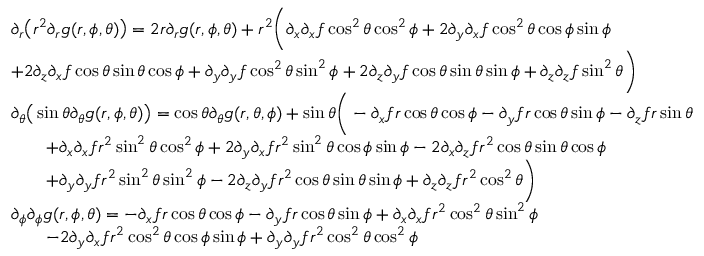<formula> <loc_0><loc_0><loc_500><loc_500>\begin{array} { r l } & { \partial _ { r } \left ( r ^ { 2 } \partial _ { r } g ( r , \phi , \theta ) \right ) = 2 r \partial _ { r } g ( r , \phi , \theta ) + r ^ { 2 } \left ( \partial _ { x } \partial _ { x } f \cos ^ { 2 } \theta \cos ^ { 2 } \phi + 2 \partial _ { y } \partial _ { x } f \cos ^ { 2 } \theta \cos \phi \sin \phi } \\ & { + 2 \partial _ { z } \partial _ { x } f \cos \theta \sin \theta \cos \phi + \partial _ { y } \partial _ { y } f \cos ^ { 2 } \theta \sin ^ { 2 } \phi + 2 \partial _ { z } \partial _ { y } f \cos \theta \sin \theta \sin \phi + \partial _ { z } \partial _ { z } f \sin ^ { 2 } \theta \right ) } \\ & { \partial _ { \theta } \left ( \sin \theta \partial _ { \theta } g ( r , \phi , \theta ) \right ) = \cos \theta \partial _ { \theta } g ( r , \theta , \phi ) + \sin \theta \left ( - \partial _ { x } f r \cos \theta \cos \phi - \partial _ { y } f r \cos \theta \sin \phi - \partial _ { z } f r \sin \theta } \\ & { \quad + \partial _ { x } \partial _ { x } f r ^ { 2 } \sin ^ { 2 } \theta \cos ^ { 2 } \phi + 2 \partial _ { y } \partial _ { x } f r ^ { 2 } \sin ^ { 2 } \theta \cos \phi \sin \phi - 2 \partial _ { x } \partial _ { z } f r ^ { 2 } \cos \theta \sin \theta \cos \phi } \\ & { \quad + \partial _ { y } \partial _ { y } f r ^ { 2 } \sin ^ { 2 } \theta \sin ^ { 2 } \phi - 2 \partial _ { z } \partial _ { y } f r ^ { 2 } \cos \theta \sin \theta \sin \phi + \partial _ { z } \partial _ { z } f r ^ { 2 } \cos ^ { 2 } \theta \right ) } \\ & { \partial _ { \phi } \partial _ { \phi } g ( r , \phi , \theta ) = - \partial _ { x } f r \cos \theta \cos \phi - \partial _ { y } f r \cos \theta \sin \phi + \partial _ { x } \partial _ { x } f r ^ { 2 } \cos ^ { 2 } \theta \sin ^ { 2 } \phi } \\ & { \quad - 2 \partial _ { y } \partial _ { x } f r ^ { 2 } \cos ^ { 2 } \theta \cos \phi \sin \phi + \partial _ { y } \partial _ { y } f r ^ { 2 } \cos ^ { 2 } \theta \cos ^ { 2 } \phi } \end{array}</formula> 